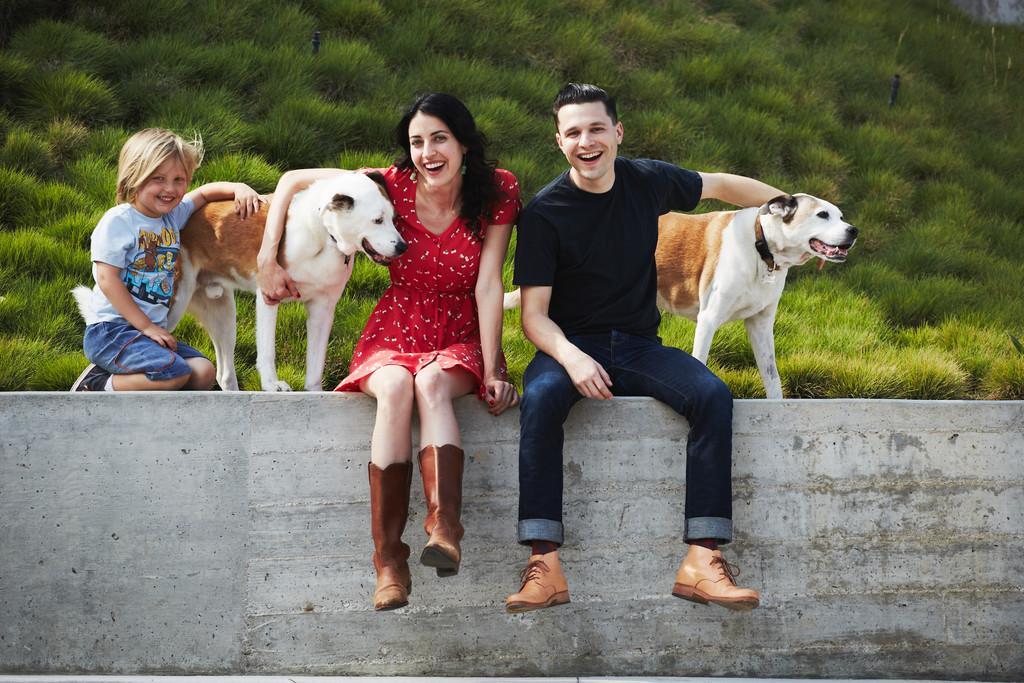Please provide a concise description of this image. This is the picture of 2 persons , 1boy and 2 dogs sitting in the wall and the back ground there is a grass. 